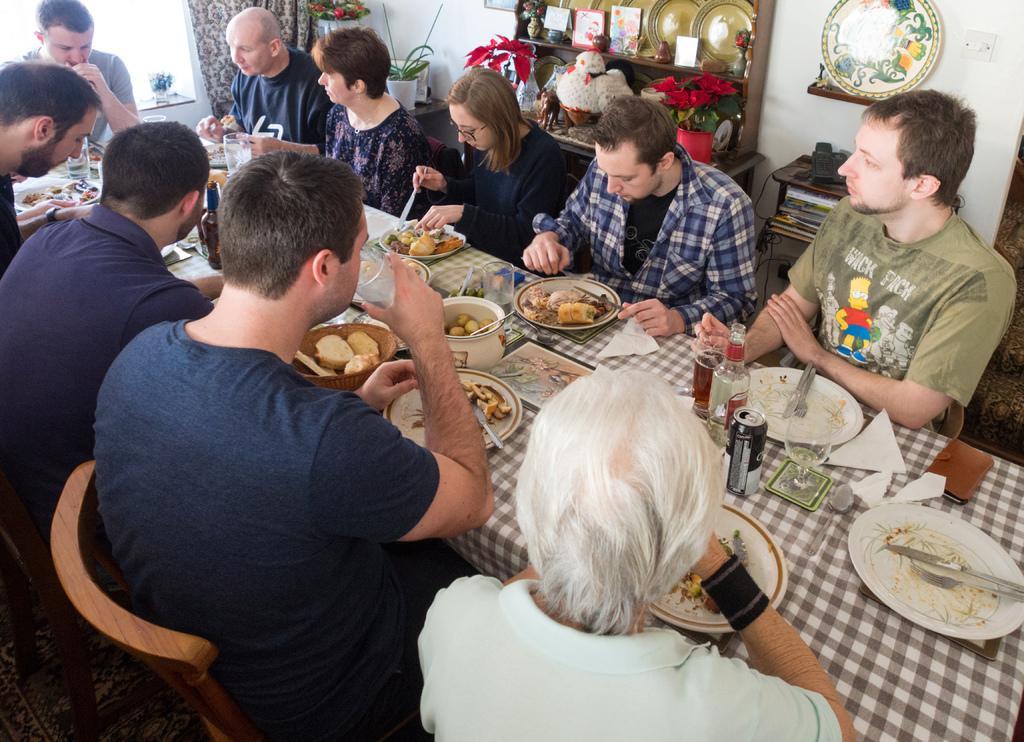Can you describe this image briefly? In this picture I can see number of people who are sitting on chairs and there is a table in front of them on which there are number of food items. In the background I see the white wall and there are few things on the shelves and on the top left of this image I see few plants and a curtain near to the plants. 